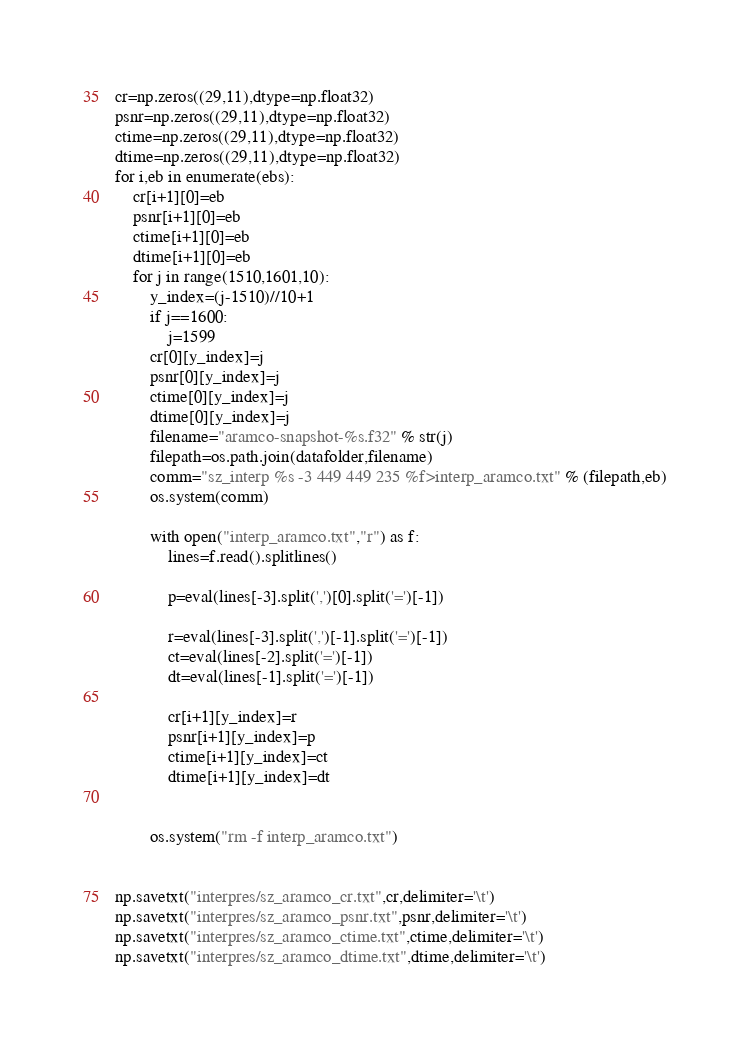<code> <loc_0><loc_0><loc_500><loc_500><_Python_>cr=np.zeros((29,11),dtype=np.float32)
psnr=np.zeros((29,11),dtype=np.float32)
ctime=np.zeros((29,11),dtype=np.float32)
dtime=np.zeros((29,11),dtype=np.float32)
for i,eb in enumerate(ebs):
    cr[i+1][0]=eb
    psnr[i+1][0]=eb
    ctime[i+1][0]=eb
    dtime[i+1][0]=eb
    for j in range(1510,1601,10):
        y_index=(j-1510)//10+1
        if j==1600:
            j=1599
        cr[0][y_index]=j
        psnr[0][y_index]=j
        ctime[0][y_index]=j
        dtime[0][y_index]=j
        filename="aramco-snapshot-%s.f32" % str(j)
        filepath=os.path.join(datafolder,filename)
        comm="sz_interp %s -3 449 449 235 %f>interp_aramco.txt" % (filepath,eb)
        os.system(comm)
       
        with open("interp_aramco.txt","r") as f:
            lines=f.read().splitlines()
            
            p=eval(lines[-3].split(',')[0].split('=')[-1])
            
            r=eval(lines[-3].split(',')[-1].split('=')[-1])
            ct=eval(lines[-2].split('=')[-1])
            dt=eval(lines[-1].split('=')[-1])
            
            cr[i+1][y_index]=r
            psnr[i+1][y_index]=p
            ctime[i+1][y_index]=ct
            dtime[i+1][y_index]=dt

        
        os.system("rm -f interp_aramco.txt")


np.savetxt("interpres/sz_aramco_cr.txt",cr,delimiter='\t')
np.savetxt("interpres/sz_aramco_psnr.txt",psnr,delimiter='\t')
np.savetxt("interpres/sz_aramco_ctime.txt",ctime,delimiter='\t')
np.savetxt("interpres/sz_aramco_dtime.txt",dtime,delimiter='\t')</code> 